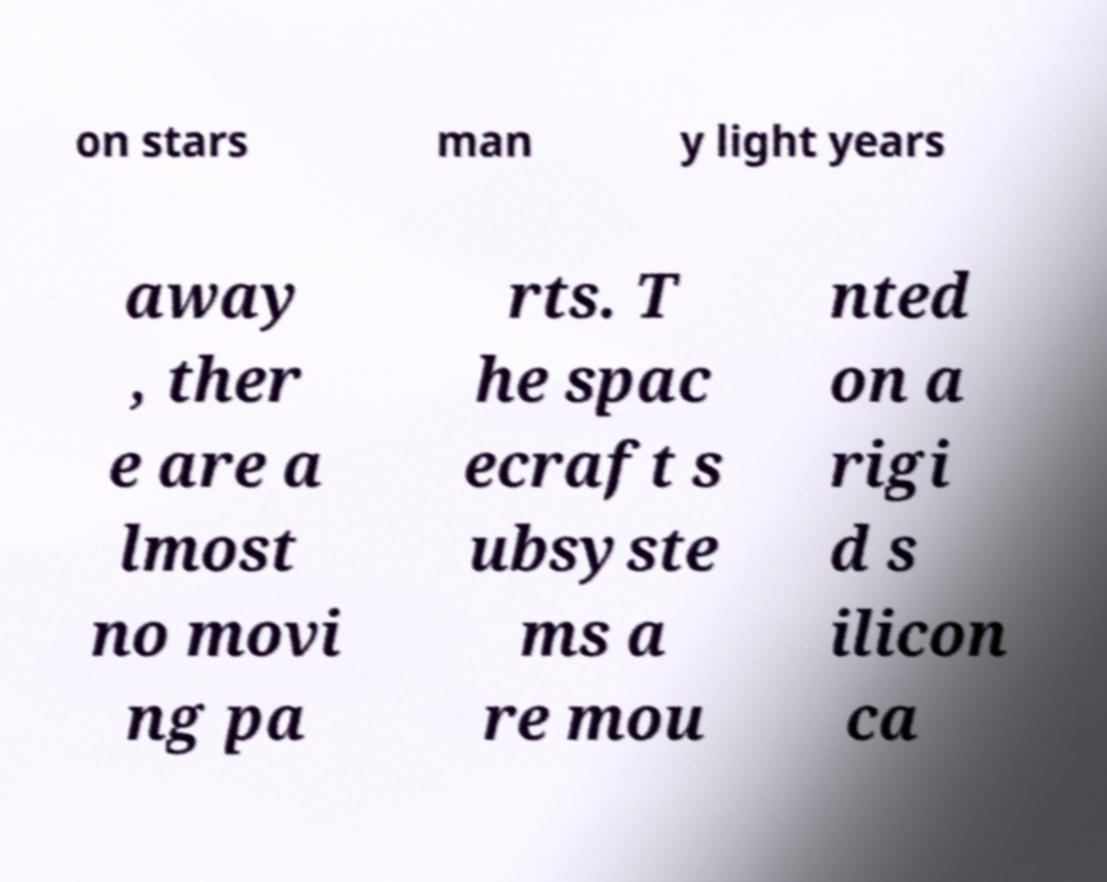Can you accurately transcribe the text from the provided image for me? on stars man y light years away , ther e are a lmost no movi ng pa rts. T he spac ecraft s ubsyste ms a re mou nted on a rigi d s ilicon ca 